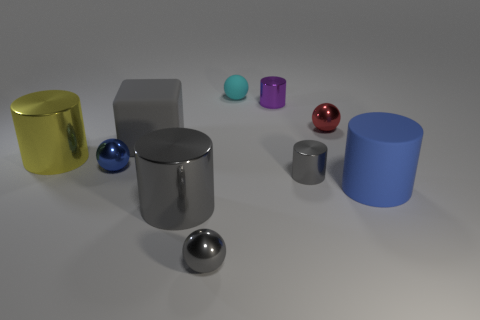What number of metal things are either large gray cylinders or tiny spheres? In the image, there are a total of three items that match the description: two large gray cylinders and one small, shiny sphere. 